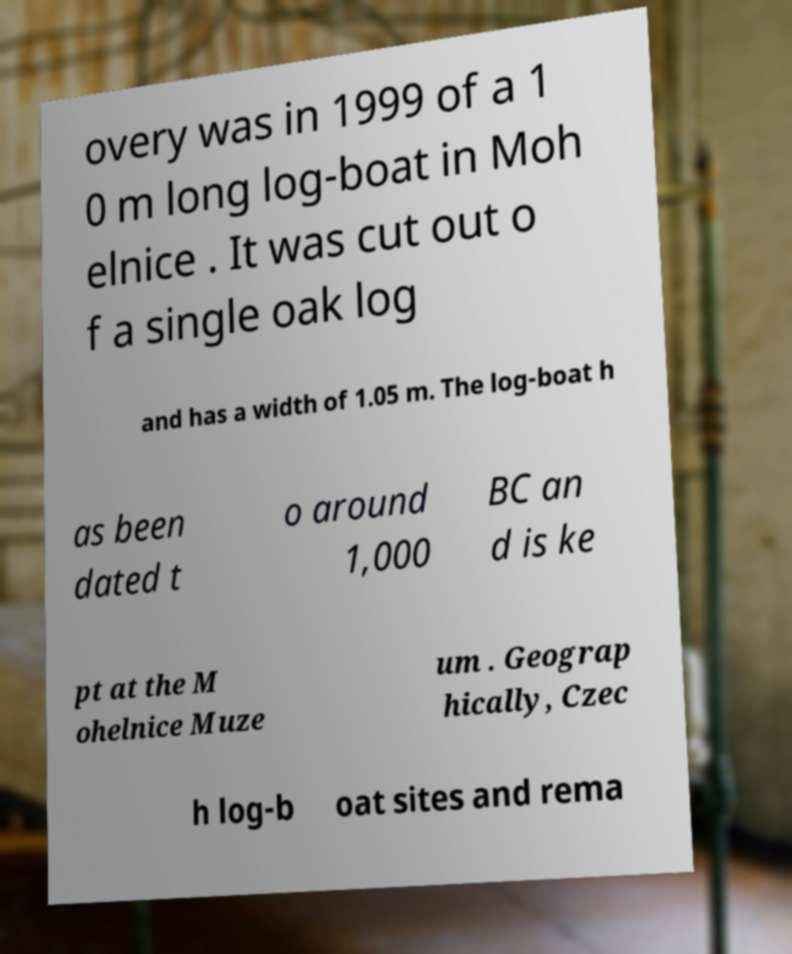For documentation purposes, I need the text within this image transcribed. Could you provide that? overy was in 1999 of a 1 0 m long log-boat in Moh elnice . It was cut out o f a single oak log and has a width of 1.05 m. The log-boat h as been dated t o around 1,000 BC an d is ke pt at the M ohelnice Muze um . Geograp hically, Czec h log-b oat sites and rema 